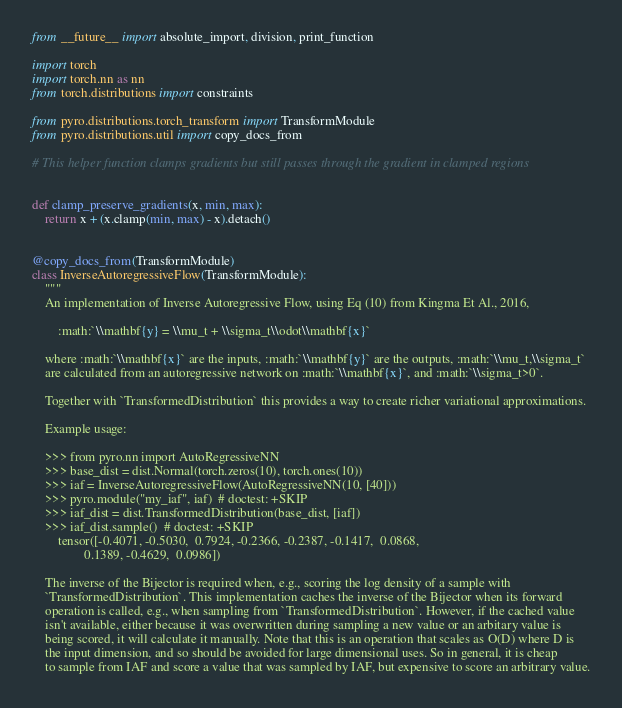<code> <loc_0><loc_0><loc_500><loc_500><_Python_>from __future__ import absolute_import, division, print_function

import torch
import torch.nn as nn
from torch.distributions import constraints

from pyro.distributions.torch_transform import TransformModule
from pyro.distributions.util import copy_docs_from

# This helper function clamps gradients but still passes through the gradient in clamped regions


def clamp_preserve_gradients(x, min, max):
    return x + (x.clamp(min, max) - x).detach()


@copy_docs_from(TransformModule)
class InverseAutoregressiveFlow(TransformModule):
    """
    An implementation of Inverse Autoregressive Flow, using Eq (10) from Kingma Et Al., 2016,

        :math:`\\mathbf{y} = \\mu_t + \\sigma_t\\odot\\mathbf{x}`

    where :math:`\\mathbf{x}` are the inputs, :math:`\\mathbf{y}` are the outputs, :math:`\\mu_t,\\sigma_t`
    are calculated from an autoregressive network on :math:`\\mathbf{x}`, and :math:`\\sigma_t>0`.

    Together with `TransformedDistribution` this provides a way to create richer variational approximations.

    Example usage:

    >>> from pyro.nn import AutoRegressiveNN
    >>> base_dist = dist.Normal(torch.zeros(10), torch.ones(10))
    >>> iaf = InverseAutoregressiveFlow(AutoRegressiveNN(10, [40]))
    >>> pyro.module("my_iaf", iaf)  # doctest: +SKIP
    >>> iaf_dist = dist.TransformedDistribution(base_dist, [iaf])
    >>> iaf_dist.sample()  # doctest: +SKIP
        tensor([-0.4071, -0.5030,  0.7924, -0.2366, -0.2387, -0.1417,  0.0868,
                0.1389, -0.4629,  0.0986])

    The inverse of the Bijector is required when, e.g., scoring the log density of a sample with
    `TransformedDistribution`. This implementation caches the inverse of the Bijector when its forward
    operation is called, e.g., when sampling from `TransformedDistribution`. However, if the cached value
    isn't available, either because it was overwritten during sampling a new value or an arbitary value is
    being scored, it will calculate it manually. Note that this is an operation that scales as O(D) where D is
    the input dimension, and so should be avoided for large dimensional uses. So in general, it is cheap
    to sample from IAF and score a value that was sampled by IAF, but expensive to score an arbitrary value.
</code> 